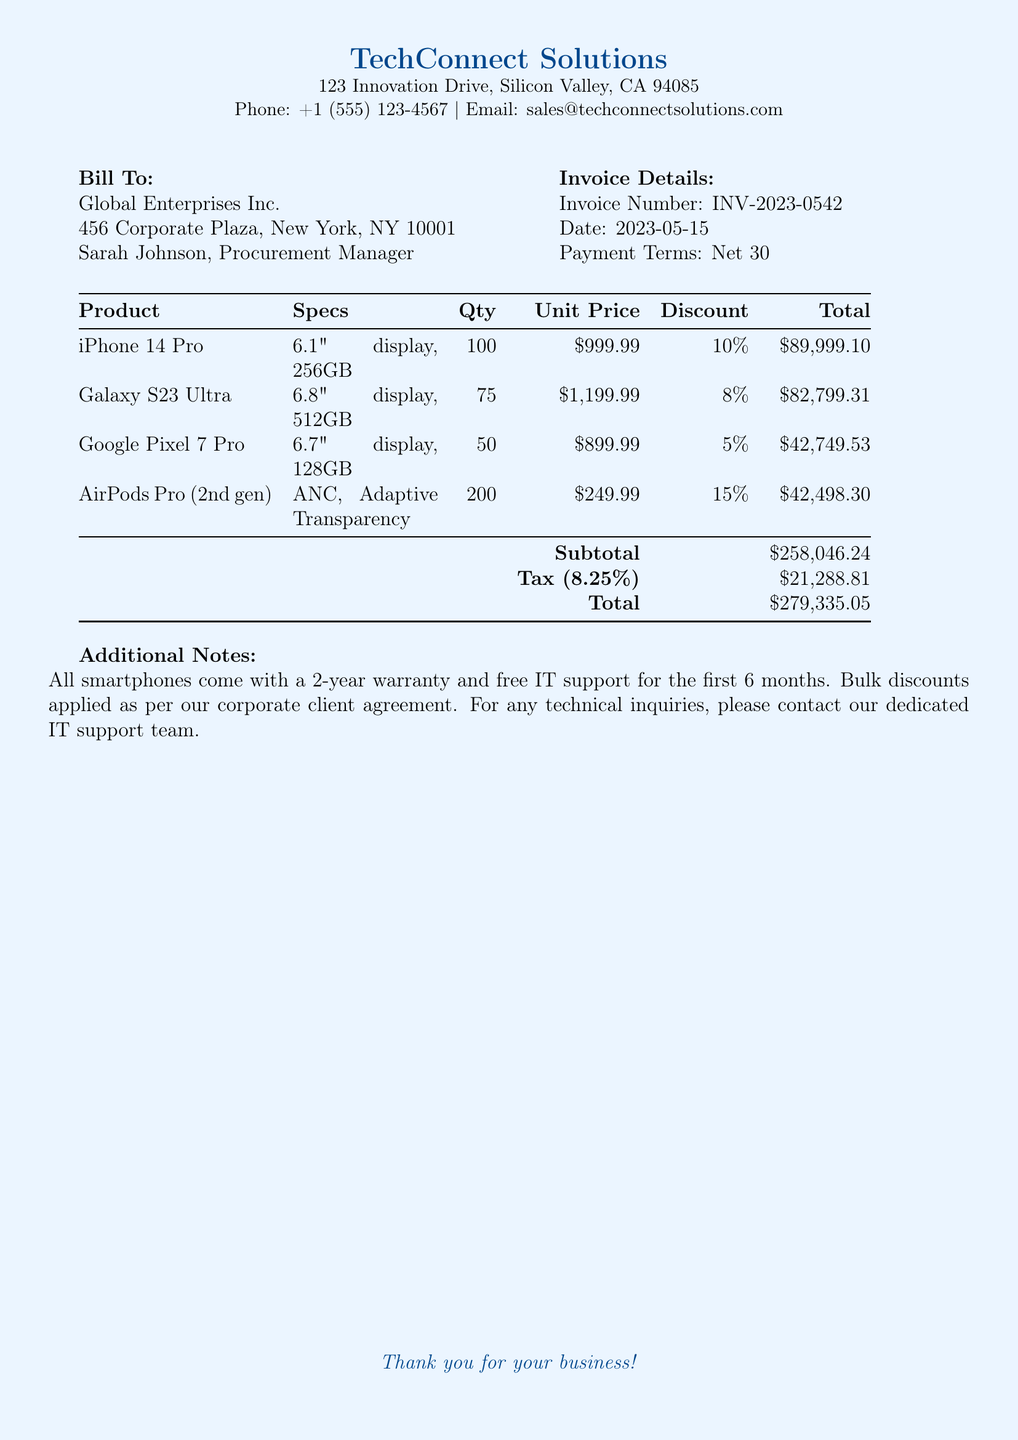What is the invoice number? The invoice number is listed in the invoice details section of the document.
Answer: INV-2023-0542 What is the total amount billed? The total amount billed is found at the bottom of the totals section in the document.
Answer: $279,335.05 How many iPhone 14 Pro units were purchased? The quantity of iPhone 14 Pro units is specified in the product table of the document.
Answer: 100 What discount percentage was applied to the Galaxy S23 Ultra? The discount for the Galaxy S23 Ultra is shown in the product table alongside the unit price.
Answer: 8% Who is the procurement manager for Global Enterprises Inc.? The procurement manager's name is mentioned in the bill-to section of the document.
Answer: Sarah Johnson What is the tax rate applied to the subtotal? The tax rate can be found in the subtotal section of the document.
Answer: 8.25% How many AirPods Pro units are included in the invoice? The number of AirPods Pro units is stated in the product table.
Answer: 200 What is included in the warranty for the smartphones? The warranty details can be found in the additional notes section of the document.
Answer: 2-year warranty What is the address of TechConnect Solutions? The address is provided in the header section of the document.
Answer: 123 Innovation Drive, Silicon Valley, CA 94085 